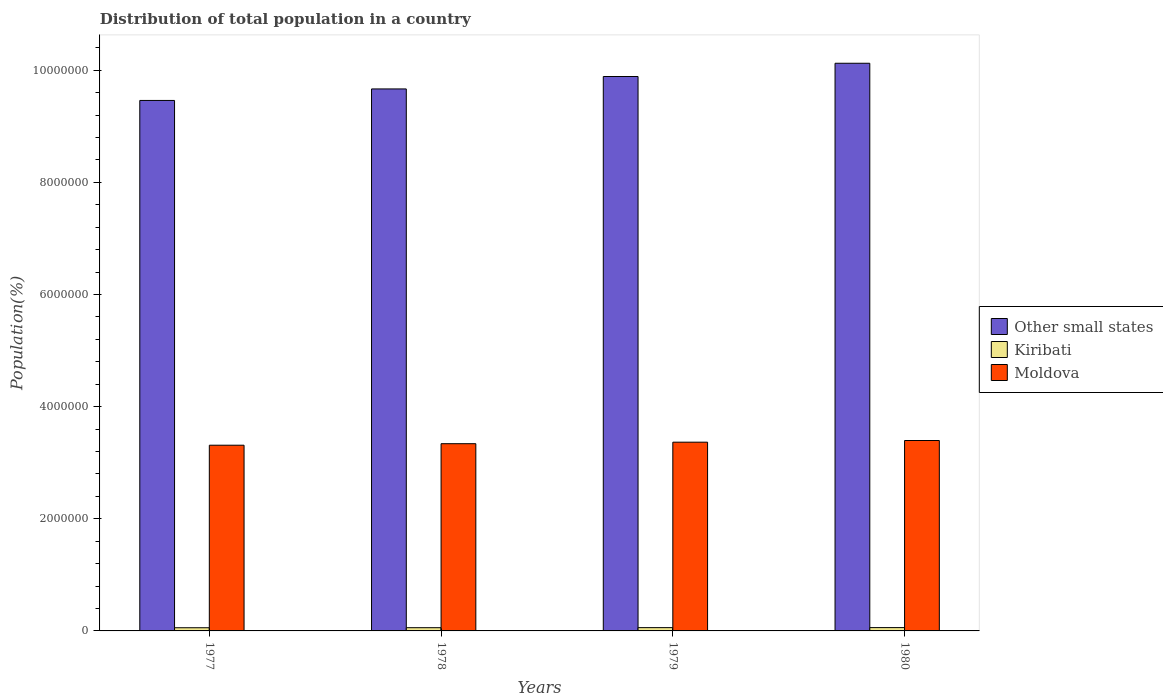Are the number of bars per tick equal to the number of legend labels?
Give a very brief answer. Yes. Are the number of bars on each tick of the X-axis equal?
Make the answer very short. Yes. How many bars are there on the 1st tick from the right?
Your response must be concise. 3. What is the label of the 4th group of bars from the left?
Provide a short and direct response. 1980. In how many cases, is the number of bars for a given year not equal to the number of legend labels?
Give a very brief answer. 0. What is the population of in Other small states in 1977?
Your answer should be very brief. 9.46e+06. Across all years, what is the maximum population of in Other small states?
Your answer should be compact. 1.01e+07. Across all years, what is the minimum population of in Other small states?
Provide a short and direct response. 9.46e+06. In which year was the population of in Moldova maximum?
Offer a terse response. 1980. In which year was the population of in Moldova minimum?
Give a very brief answer. 1977. What is the total population of in Kiribati in the graph?
Offer a terse response. 2.32e+05. What is the difference between the population of in Other small states in 1978 and that in 1979?
Your answer should be very brief. -2.21e+05. What is the difference between the population of in Moldova in 1978 and the population of in Kiribati in 1979?
Offer a very short reply. 3.28e+06. What is the average population of in Kiribati per year?
Keep it short and to the point. 5.81e+04. In the year 1978, what is the difference between the population of in Moldova and population of in Kiribati?
Your response must be concise. 3.28e+06. What is the ratio of the population of in Kiribati in 1978 to that in 1980?
Keep it short and to the point. 0.97. What is the difference between the highest and the second highest population of in Other small states?
Your answer should be very brief. 2.36e+05. What is the difference between the highest and the lowest population of in Moldova?
Offer a terse response. 8.40e+04. In how many years, is the population of in Kiribati greater than the average population of in Kiribati taken over all years?
Give a very brief answer. 2. Is the sum of the population of in Kiribati in 1978 and 1979 greater than the maximum population of in Other small states across all years?
Give a very brief answer. No. What does the 3rd bar from the left in 1979 represents?
Ensure brevity in your answer.  Moldova. What does the 2nd bar from the right in 1980 represents?
Keep it short and to the point. Kiribati. How many bars are there?
Offer a very short reply. 12. What is the difference between two consecutive major ticks on the Y-axis?
Give a very brief answer. 2.00e+06. Are the values on the major ticks of Y-axis written in scientific E-notation?
Ensure brevity in your answer.  No. Does the graph contain any zero values?
Offer a very short reply. No. Does the graph contain grids?
Your answer should be compact. No. Where does the legend appear in the graph?
Provide a short and direct response. Center right. How are the legend labels stacked?
Keep it short and to the point. Vertical. What is the title of the graph?
Offer a very short reply. Distribution of total population in a country. Does "Zimbabwe" appear as one of the legend labels in the graph?
Your answer should be very brief. No. What is the label or title of the X-axis?
Give a very brief answer. Years. What is the label or title of the Y-axis?
Your answer should be very brief. Population(%). What is the Population(%) of Other small states in 1977?
Provide a succinct answer. 9.46e+06. What is the Population(%) in Kiribati in 1977?
Give a very brief answer. 5.68e+04. What is the Population(%) of Moldova in 1977?
Make the answer very short. 3.31e+06. What is the Population(%) in Other small states in 1978?
Provide a succinct answer. 9.67e+06. What is the Population(%) in Kiribati in 1978?
Keep it short and to the point. 5.77e+04. What is the Population(%) of Moldova in 1978?
Provide a succinct answer. 3.34e+06. What is the Population(%) of Other small states in 1979?
Offer a very short reply. 9.89e+06. What is the Population(%) in Kiribati in 1979?
Your answer should be compact. 5.85e+04. What is the Population(%) in Moldova in 1979?
Make the answer very short. 3.37e+06. What is the Population(%) in Other small states in 1980?
Make the answer very short. 1.01e+07. What is the Population(%) in Kiribati in 1980?
Offer a very short reply. 5.93e+04. What is the Population(%) of Moldova in 1980?
Make the answer very short. 3.40e+06. Across all years, what is the maximum Population(%) of Other small states?
Your answer should be very brief. 1.01e+07. Across all years, what is the maximum Population(%) of Kiribati?
Keep it short and to the point. 5.93e+04. Across all years, what is the maximum Population(%) in Moldova?
Make the answer very short. 3.40e+06. Across all years, what is the minimum Population(%) in Other small states?
Provide a short and direct response. 9.46e+06. Across all years, what is the minimum Population(%) in Kiribati?
Keep it short and to the point. 5.68e+04. Across all years, what is the minimum Population(%) in Moldova?
Make the answer very short. 3.31e+06. What is the total Population(%) of Other small states in the graph?
Offer a very short reply. 3.91e+07. What is the total Population(%) of Kiribati in the graph?
Give a very brief answer. 2.32e+05. What is the total Population(%) of Moldova in the graph?
Keep it short and to the point. 1.34e+07. What is the difference between the Population(%) in Other small states in 1977 and that in 1978?
Offer a terse response. -2.05e+05. What is the difference between the Population(%) of Kiribati in 1977 and that in 1978?
Offer a terse response. -849. What is the difference between the Population(%) in Moldova in 1977 and that in 1978?
Make the answer very short. -2.70e+04. What is the difference between the Population(%) in Other small states in 1977 and that in 1979?
Make the answer very short. -4.27e+05. What is the difference between the Population(%) of Kiribati in 1977 and that in 1979?
Your answer should be very brief. -1694. What is the difference between the Population(%) of Moldova in 1977 and that in 1979?
Offer a very short reply. -5.40e+04. What is the difference between the Population(%) of Other small states in 1977 and that in 1980?
Ensure brevity in your answer.  -6.63e+05. What is the difference between the Population(%) in Kiribati in 1977 and that in 1980?
Make the answer very short. -2525. What is the difference between the Population(%) of Moldova in 1977 and that in 1980?
Your response must be concise. -8.40e+04. What is the difference between the Population(%) in Other small states in 1978 and that in 1979?
Ensure brevity in your answer.  -2.21e+05. What is the difference between the Population(%) in Kiribati in 1978 and that in 1979?
Make the answer very short. -845. What is the difference between the Population(%) in Moldova in 1978 and that in 1979?
Your response must be concise. -2.70e+04. What is the difference between the Population(%) in Other small states in 1978 and that in 1980?
Make the answer very short. -4.58e+05. What is the difference between the Population(%) of Kiribati in 1978 and that in 1980?
Provide a succinct answer. -1676. What is the difference between the Population(%) in Moldova in 1978 and that in 1980?
Give a very brief answer. -5.70e+04. What is the difference between the Population(%) in Other small states in 1979 and that in 1980?
Give a very brief answer. -2.36e+05. What is the difference between the Population(%) of Kiribati in 1979 and that in 1980?
Give a very brief answer. -831. What is the difference between the Population(%) in Moldova in 1979 and that in 1980?
Offer a terse response. -3.00e+04. What is the difference between the Population(%) of Other small states in 1977 and the Population(%) of Kiribati in 1978?
Your response must be concise. 9.40e+06. What is the difference between the Population(%) of Other small states in 1977 and the Population(%) of Moldova in 1978?
Provide a short and direct response. 6.12e+06. What is the difference between the Population(%) of Kiribati in 1977 and the Population(%) of Moldova in 1978?
Your answer should be compact. -3.28e+06. What is the difference between the Population(%) of Other small states in 1977 and the Population(%) of Kiribati in 1979?
Keep it short and to the point. 9.40e+06. What is the difference between the Population(%) of Other small states in 1977 and the Population(%) of Moldova in 1979?
Provide a short and direct response. 6.09e+06. What is the difference between the Population(%) in Kiribati in 1977 and the Population(%) in Moldova in 1979?
Give a very brief answer. -3.31e+06. What is the difference between the Population(%) in Other small states in 1977 and the Population(%) in Kiribati in 1980?
Give a very brief answer. 9.40e+06. What is the difference between the Population(%) in Other small states in 1977 and the Population(%) in Moldova in 1980?
Your answer should be compact. 6.06e+06. What is the difference between the Population(%) of Kiribati in 1977 and the Population(%) of Moldova in 1980?
Keep it short and to the point. -3.34e+06. What is the difference between the Population(%) of Other small states in 1978 and the Population(%) of Kiribati in 1979?
Your response must be concise. 9.61e+06. What is the difference between the Population(%) of Other small states in 1978 and the Population(%) of Moldova in 1979?
Make the answer very short. 6.30e+06. What is the difference between the Population(%) in Kiribati in 1978 and the Population(%) in Moldova in 1979?
Offer a terse response. -3.31e+06. What is the difference between the Population(%) of Other small states in 1978 and the Population(%) of Kiribati in 1980?
Ensure brevity in your answer.  9.61e+06. What is the difference between the Population(%) in Other small states in 1978 and the Population(%) in Moldova in 1980?
Offer a very short reply. 6.27e+06. What is the difference between the Population(%) of Kiribati in 1978 and the Population(%) of Moldova in 1980?
Offer a very short reply. -3.34e+06. What is the difference between the Population(%) in Other small states in 1979 and the Population(%) in Kiribati in 1980?
Ensure brevity in your answer.  9.83e+06. What is the difference between the Population(%) of Other small states in 1979 and the Population(%) of Moldova in 1980?
Give a very brief answer. 6.49e+06. What is the difference between the Population(%) of Kiribati in 1979 and the Population(%) of Moldova in 1980?
Provide a succinct answer. -3.34e+06. What is the average Population(%) in Other small states per year?
Ensure brevity in your answer.  9.78e+06. What is the average Population(%) of Kiribati per year?
Your response must be concise. 5.81e+04. What is the average Population(%) of Moldova per year?
Your response must be concise. 3.35e+06. In the year 1977, what is the difference between the Population(%) of Other small states and Population(%) of Kiribati?
Give a very brief answer. 9.40e+06. In the year 1977, what is the difference between the Population(%) in Other small states and Population(%) in Moldova?
Provide a succinct answer. 6.15e+06. In the year 1977, what is the difference between the Population(%) in Kiribati and Population(%) in Moldova?
Provide a short and direct response. -3.26e+06. In the year 1978, what is the difference between the Population(%) of Other small states and Population(%) of Kiribati?
Ensure brevity in your answer.  9.61e+06. In the year 1978, what is the difference between the Population(%) of Other small states and Population(%) of Moldova?
Ensure brevity in your answer.  6.33e+06. In the year 1978, what is the difference between the Population(%) of Kiribati and Population(%) of Moldova?
Offer a very short reply. -3.28e+06. In the year 1979, what is the difference between the Population(%) in Other small states and Population(%) in Kiribati?
Provide a succinct answer. 9.83e+06. In the year 1979, what is the difference between the Population(%) of Other small states and Population(%) of Moldova?
Your response must be concise. 6.52e+06. In the year 1979, what is the difference between the Population(%) in Kiribati and Population(%) in Moldova?
Provide a short and direct response. -3.31e+06. In the year 1980, what is the difference between the Population(%) of Other small states and Population(%) of Kiribati?
Make the answer very short. 1.01e+07. In the year 1980, what is the difference between the Population(%) of Other small states and Population(%) of Moldova?
Your answer should be compact. 6.73e+06. In the year 1980, what is the difference between the Population(%) in Kiribati and Population(%) in Moldova?
Give a very brief answer. -3.34e+06. What is the ratio of the Population(%) of Other small states in 1977 to that in 1978?
Your answer should be compact. 0.98. What is the ratio of the Population(%) of Moldova in 1977 to that in 1978?
Offer a terse response. 0.99. What is the ratio of the Population(%) of Other small states in 1977 to that in 1979?
Ensure brevity in your answer.  0.96. What is the ratio of the Population(%) in Kiribati in 1977 to that in 1979?
Keep it short and to the point. 0.97. What is the ratio of the Population(%) of Moldova in 1977 to that in 1979?
Your response must be concise. 0.98. What is the ratio of the Population(%) in Other small states in 1977 to that in 1980?
Your response must be concise. 0.93. What is the ratio of the Population(%) of Kiribati in 1977 to that in 1980?
Ensure brevity in your answer.  0.96. What is the ratio of the Population(%) of Moldova in 1977 to that in 1980?
Your answer should be compact. 0.98. What is the ratio of the Population(%) in Other small states in 1978 to that in 1979?
Ensure brevity in your answer.  0.98. What is the ratio of the Population(%) in Kiribati in 1978 to that in 1979?
Ensure brevity in your answer.  0.99. What is the ratio of the Population(%) of Moldova in 1978 to that in 1979?
Your answer should be very brief. 0.99. What is the ratio of the Population(%) of Other small states in 1978 to that in 1980?
Keep it short and to the point. 0.95. What is the ratio of the Population(%) in Kiribati in 1978 to that in 1980?
Your answer should be very brief. 0.97. What is the ratio of the Population(%) of Moldova in 1978 to that in 1980?
Give a very brief answer. 0.98. What is the ratio of the Population(%) in Other small states in 1979 to that in 1980?
Your response must be concise. 0.98. What is the difference between the highest and the second highest Population(%) of Other small states?
Ensure brevity in your answer.  2.36e+05. What is the difference between the highest and the second highest Population(%) in Kiribati?
Offer a terse response. 831. What is the difference between the highest and the lowest Population(%) of Other small states?
Make the answer very short. 6.63e+05. What is the difference between the highest and the lowest Population(%) of Kiribati?
Give a very brief answer. 2525. What is the difference between the highest and the lowest Population(%) of Moldova?
Offer a terse response. 8.40e+04. 